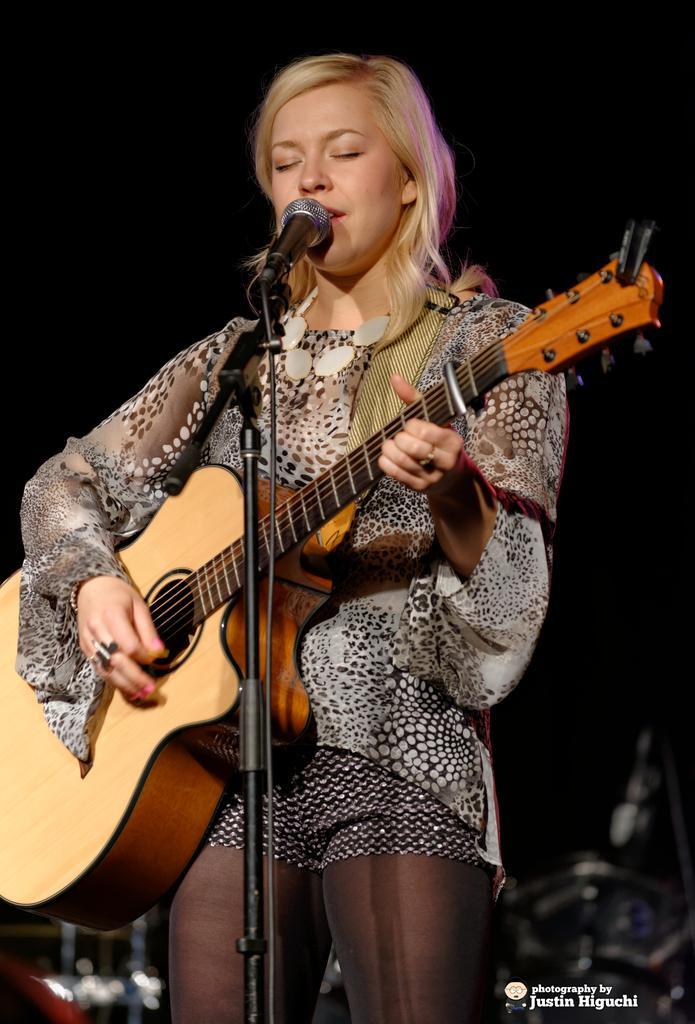Could you give a brief overview of what you see in this image? In this image we can see a woman holding a guitar in her hands and playing it. This is the mic through which she is singing. 